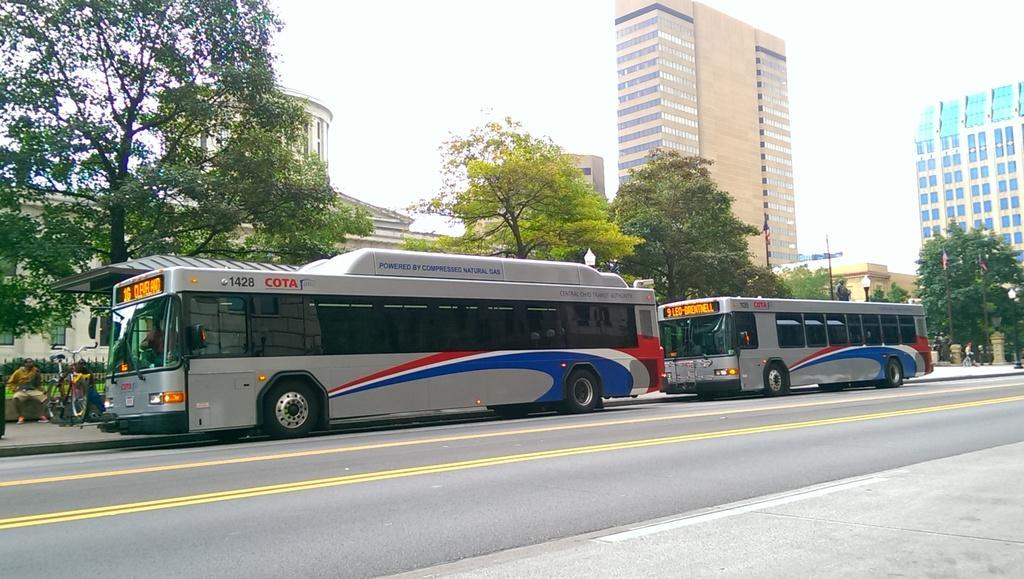In one or two sentences, can you explain what this image depicts? In this image in front there are two buses on the road. On the left side of the image there are two people sitting on the platform. Behind them there is a metal fence. In the background of the image there are trees, buildings, lights and sky. 